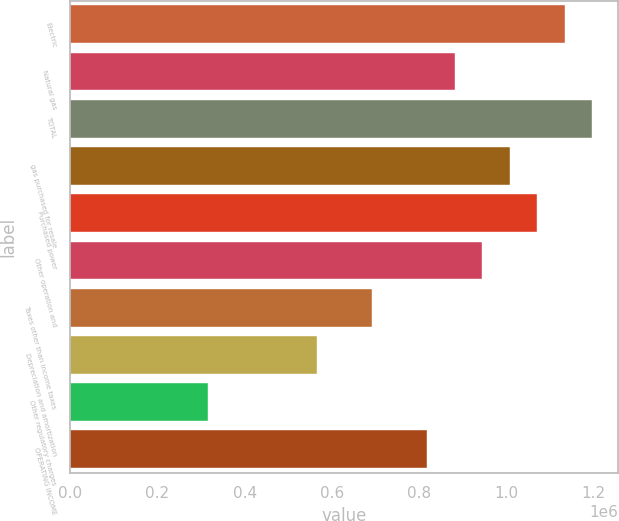<chart> <loc_0><loc_0><loc_500><loc_500><bar_chart><fcel>Electric<fcel>Natural gas<fcel>TOTAL<fcel>gas purchased for resale<fcel>Purchased power<fcel>Other operation and<fcel>Taxes other than income taxes<fcel>Depreciation and amortization<fcel>Other regulatory charges<fcel>OPERATING INCOME<nl><fcel>1.13421e+06<fcel>882197<fcel>1.19721e+06<fcel>1.0082e+06<fcel>1.07121e+06<fcel>945200<fcel>693188<fcel>567182<fcel>315170<fcel>819194<nl></chart> 